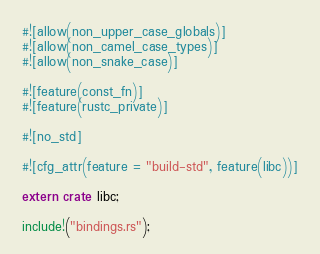Convert code to text. <code><loc_0><loc_0><loc_500><loc_500><_Rust_>#![allow(non_upper_case_globals)]
#![allow(non_camel_case_types)]
#![allow(non_snake_case)]

#![feature(const_fn)] 
#![feature(rustc_private)]

#![no_std]

#![cfg_attr(feature = "build-std", feature(libc))]

extern crate libc;

include!("bindings.rs");</code> 